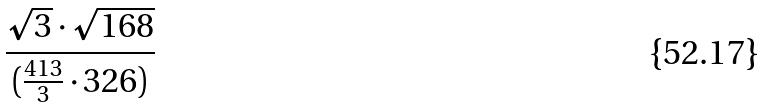Convert formula to latex. <formula><loc_0><loc_0><loc_500><loc_500>\frac { \sqrt { 3 } \cdot \sqrt { 1 6 8 } } { ( \frac { 4 1 3 } { 3 } \cdot 3 2 6 ) }</formula> 